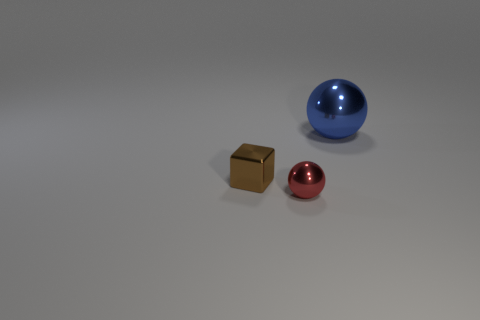Is the number of metallic spheres that are behind the red object the same as the number of small metal things that are on the left side of the small block?
Ensure brevity in your answer.  No. What number of other objects are there of the same color as the tiny block?
Provide a short and direct response. 0. Is the color of the big object the same as the metallic object on the left side of the small red metal object?
Your answer should be very brief. No. What number of gray objects are blocks or small metallic balls?
Offer a terse response. 0. Is the number of red metal balls that are behind the small sphere the same as the number of large green matte cylinders?
Provide a succinct answer. Yes. Are there any other things that have the same size as the blue metallic thing?
Ensure brevity in your answer.  No. What is the color of the other tiny object that is the same shape as the blue thing?
Your answer should be very brief. Red. What number of small shiny things have the same shape as the big blue shiny thing?
Make the answer very short. 1. How many small brown cubes are there?
Your response must be concise. 1. Is there a small brown cube made of the same material as the red sphere?
Offer a terse response. Yes. 